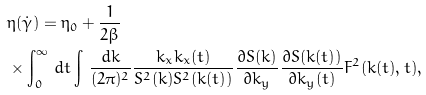Convert formula to latex. <formula><loc_0><loc_0><loc_500><loc_500>& \eta ( \dot { \gamma } ) = \eta _ { 0 } + \frac { 1 } { 2 \beta } \\ & \times \int _ { 0 } ^ { \infty } \, d t \int \, \frac { { d } { k } } { ( 2 \pi ) ^ { 2 } } \frac { k _ { x } k _ { x } ( t ) } { S ^ { 2 } ( k ) S ^ { 2 } ( k ( t ) ) } \frac { \partial S ( k ) } { \partial k _ { y } } \frac { \partial S ( k ( t ) ) } { \partial k _ { y } ( t ) } F ^ { 2 } ( { k } ( t ) , t ) ,</formula> 